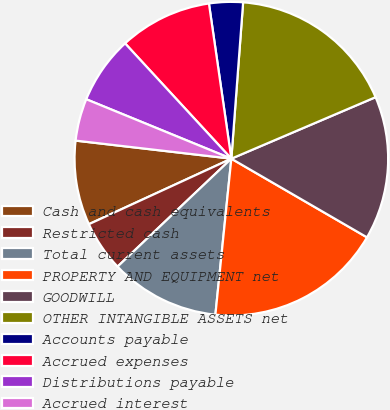<chart> <loc_0><loc_0><loc_500><loc_500><pie_chart><fcel>Cash and cash equivalents<fcel>Restricted cash<fcel>Total current assets<fcel>PROPERTY AND EQUIPMENT net<fcel>GOODWILL<fcel>OTHER INTANGIBLE ASSETS net<fcel>Accounts payable<fcel>Accrued expenses<fcel>Distributions payable<fcel>Accrued interest<nl><fcel>8.7%<fcel>5.22%<fcel>11.3%<fcel>18.26%<fcel>14.78%<fcel>17.39%<fcel>3.48%<fcel>9.57%<fcel>6.96%<fcel>4.35%<nl></chart> 